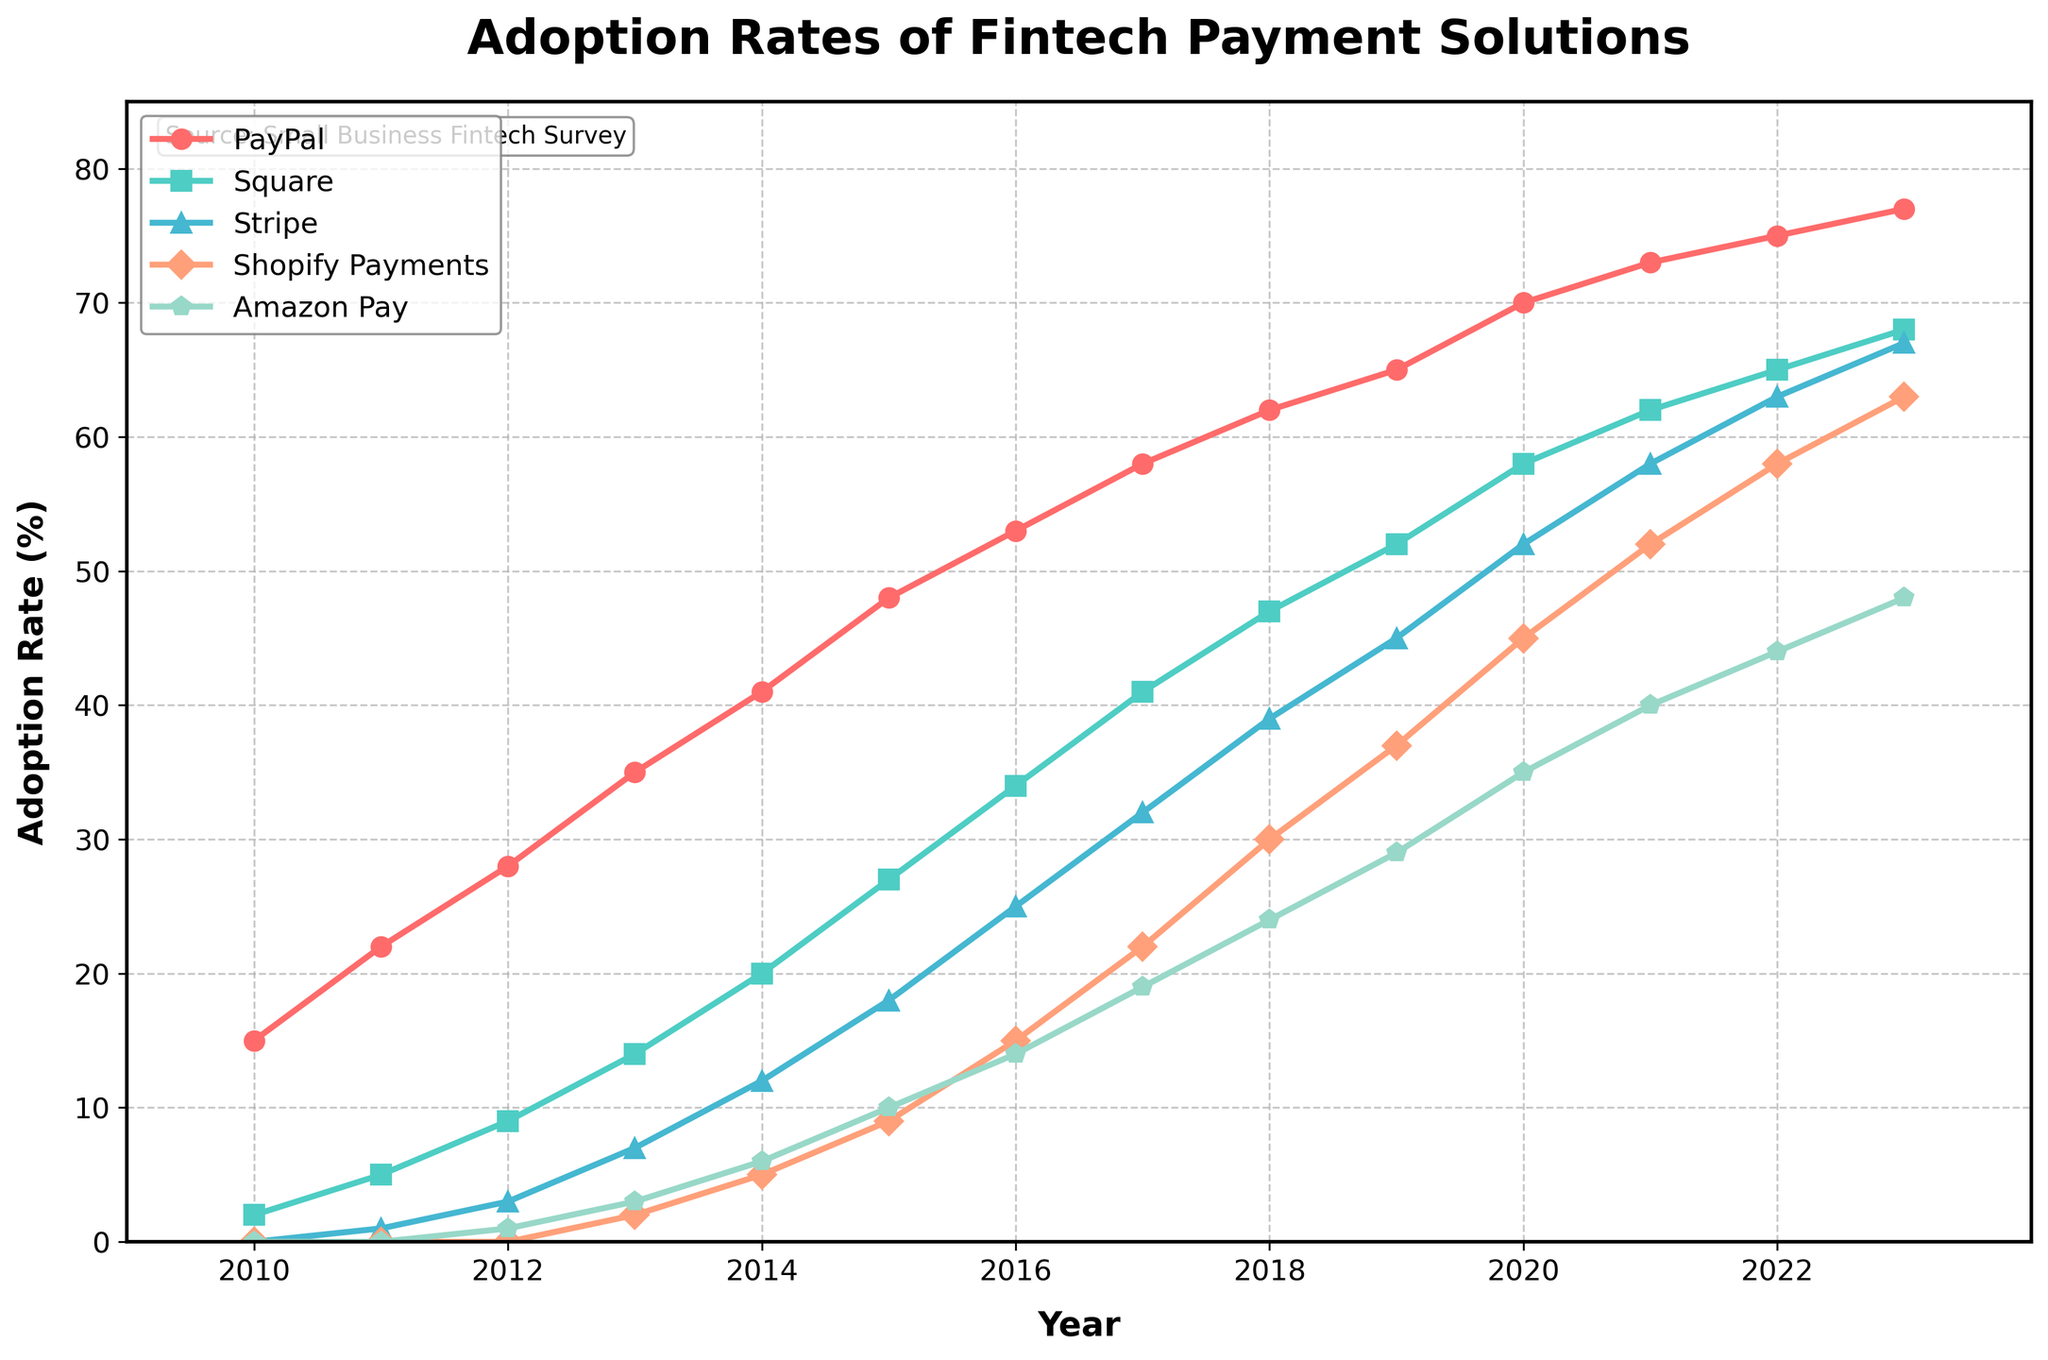How has the adoption rate of PayPal changed from 2010 to 2023? To find the change in adoption rate of PayPal from 2010 to 2023, subtract the 2010 adoption rate from the 2023 adoption rate. That is, 77 (in 2023) - 15 (in 2010).
Answer: 62 Which fintech payment solution had the highest adoption rate in 2023? Observe the adoption rates for all fintech payment solutions in 2023; the highest value is for PayPal at 77%.
Answer: PayPal Compare the adoption rates of Square and Stripe in 2015. Which one was higher and by how much? Look at the chart to identify the adoption rates in 2015 for both solutions: Square is at 27% and Stripe is at 18%. Subtract the Stripe rate from the Square rate to find the difference.
Answer: Square by 9% What is the average adoption rate of Shopify Payments from 2019 to 2023? Sum the adoption rates of Shopify Payments for the years 2019, 2020, 2021, 2022, and 2023 and then divide by 5. The sum is 37 + 45 + 52 + 58 + 63 = 255, so the average is 255 / 5.
Answer: 51 Which fintech solution saw the most significant increase in adoption rate between 2011 and 2014? Calculate the difference in adoption rates between 2011 and 2014 for all solutions: PayPal (41-22=19), Square (20-5=15), Stripe (12-1=11), Shopify Payments (5-0=5), Amazon Pay (6-0=6). PayPal has the largest increase at 19%.
Answer: PayPal What was the trend in the adoption rate of Amazon Pay from 2012 to 2023? Examine the chart for Amazon Pay's adoption rates between these years: 1, 3, 6, 10, 14, 19, 24, 29, 35, 40, 44, 48. Notice that the rate continuously increased over the years.
Answer: Increasing trend Is the adoption rate of Stripe in 2021 greater than that of Square in 2014? Check the adoption rates of Stripe in 2021 (58) and Square in 2014 (20). Notice that 58 is greater than 20.
Answer: Yes What is the median adoption rate of PayPal for the years 2010 to 2019? Arrange the adoption rates of PayPal from 2010 to 2019 in ascending order and find the middle value, which is the median of an odd number of observations. The rates are [15, 22, 28, 35, 41, 48, 53, 58, 62, 65]. Thus, the median is (48+53)/2.
Answer: 50.5 Between which consecutive years did Shopify Payments see the highest growth in adoption rate? Calculate the year-to-year difference in adoption rates for Shopify Payments: 2-0, 5-2, 9-5, 15-9, 22-15, 30-22, 37-30, 45-37, 52-45, 58-52, 63-58. The largest difference is between 2018 and 2019 (45-37=8).
Answer: 2018 and 2019 Can you identify the year when PayPal's adoption rate first surpassed 50%? Look at the adoption rates for PayPal over the years, and identify the first year when the adoption rate is above 50%. This occurs in 2016 when the rate is 53%.
Answer: 2016 